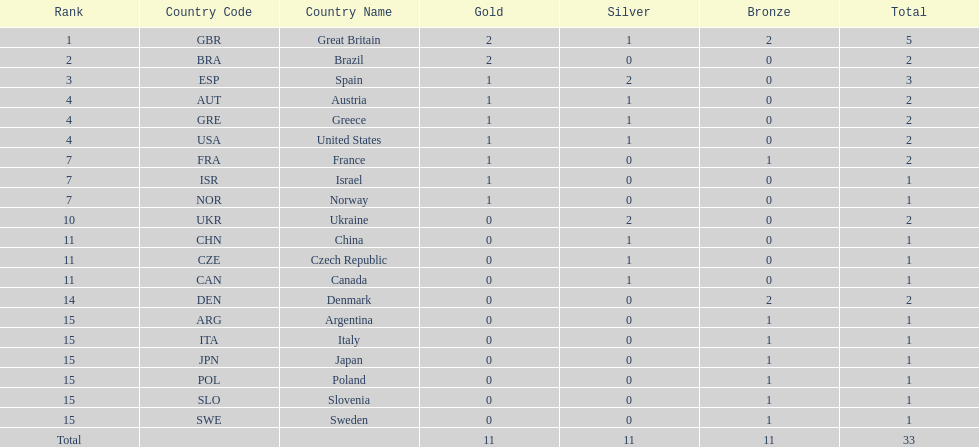Which nation was the only one to receive 3 medals? Spain (ESP). 